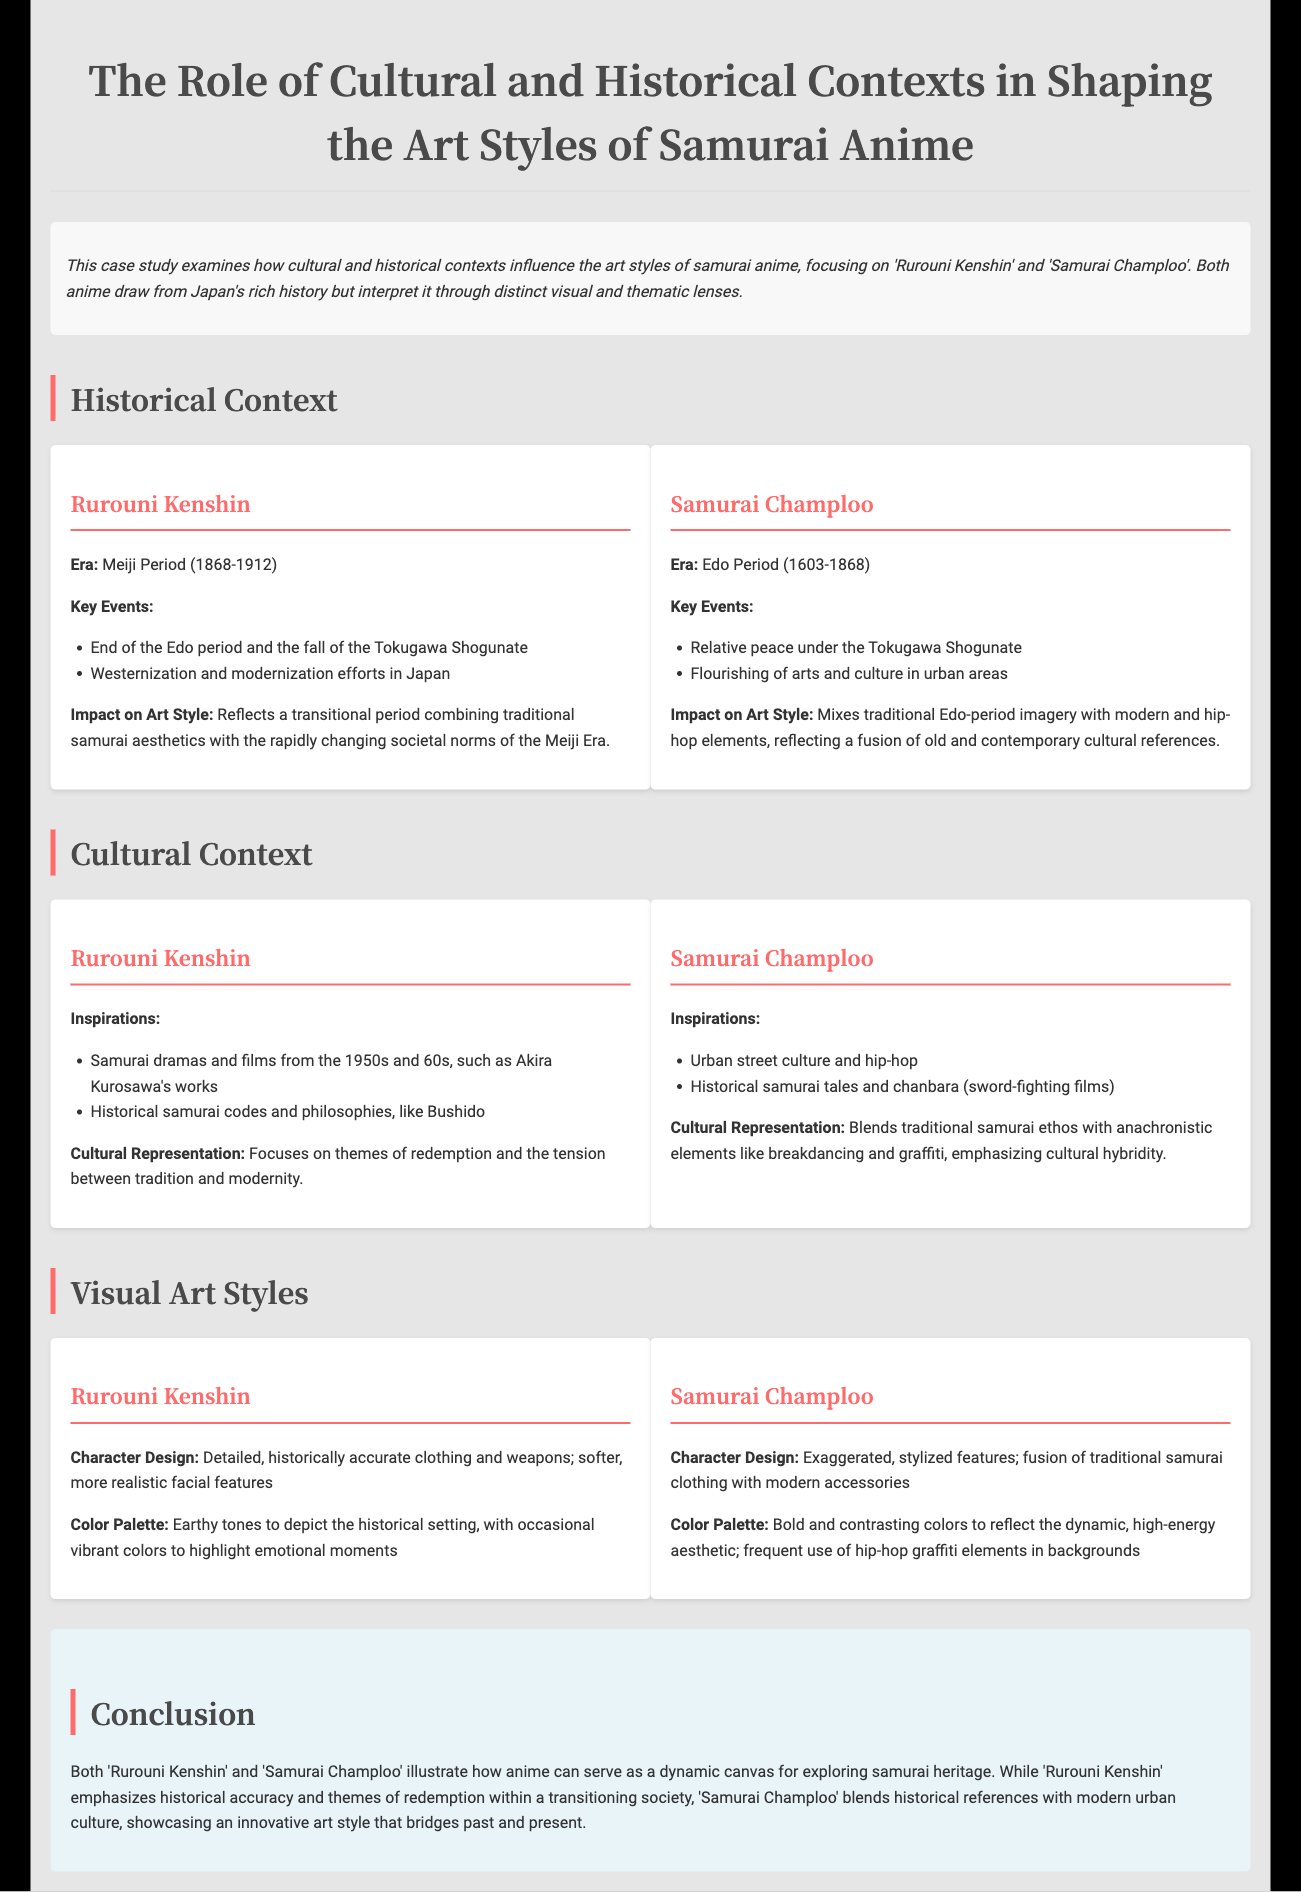What era does Rurouni Kenshin take place in? The document states that Rurouni Kenshin is set in the Meiji Period (1868-1912).
Answer: Meiji Period (1868-1912) What key event marks the historical context of Samurai Champloo? According to the document, a key event is the relative peace under the Tokugawa Shogunate.
Answer: Relative peace under the Tokugawa Shogunate Name two inspirations for Rurouni Kenshin. The document lists inspirations such as samurai dramas and films from the 1950s and 60s and historical samurai codes and philosophies like Bushido.
Answer: Samurai dramas and historical samurai codes What character design style is noted for Samurai Champloo? The document describes Samurai Champloo's character design as exaggerated, stylized features.
Answer: Exaggerated, stylized features What type of cultural representation does Rurouni Kenshin focus on? According to the text, Rurouni Kenshin emphasizes themes of redemption and the tension between tradition and modernity.
Answer: Redemption and tension between tradition and modernity How does the color palette of Samurai Champloo differ from Rurouni Kenshin? The document indicates that Samurai Champloo uses bold and contrasting colors, while Rurouni Kenshin employs earthy tones.
Answer: Bold and contrasting colors What period does Samurai Champloo depict? The document specifies that Samurai Champloo takes place during the Edo Period (1603-1868).
Answer: Edo Period (1603-1868) What themes are explored in Samurai Champloo? The study highlights that Samurai Champloo blends traditional samurai ethos with modern and hip-hop elements, emphasizing cultural hybridity.
Answer: Cultural hybridity 